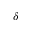Convert formula to latex. <formula><loc_0><loc_0><loc_500><loc_500>\delta</formula> 